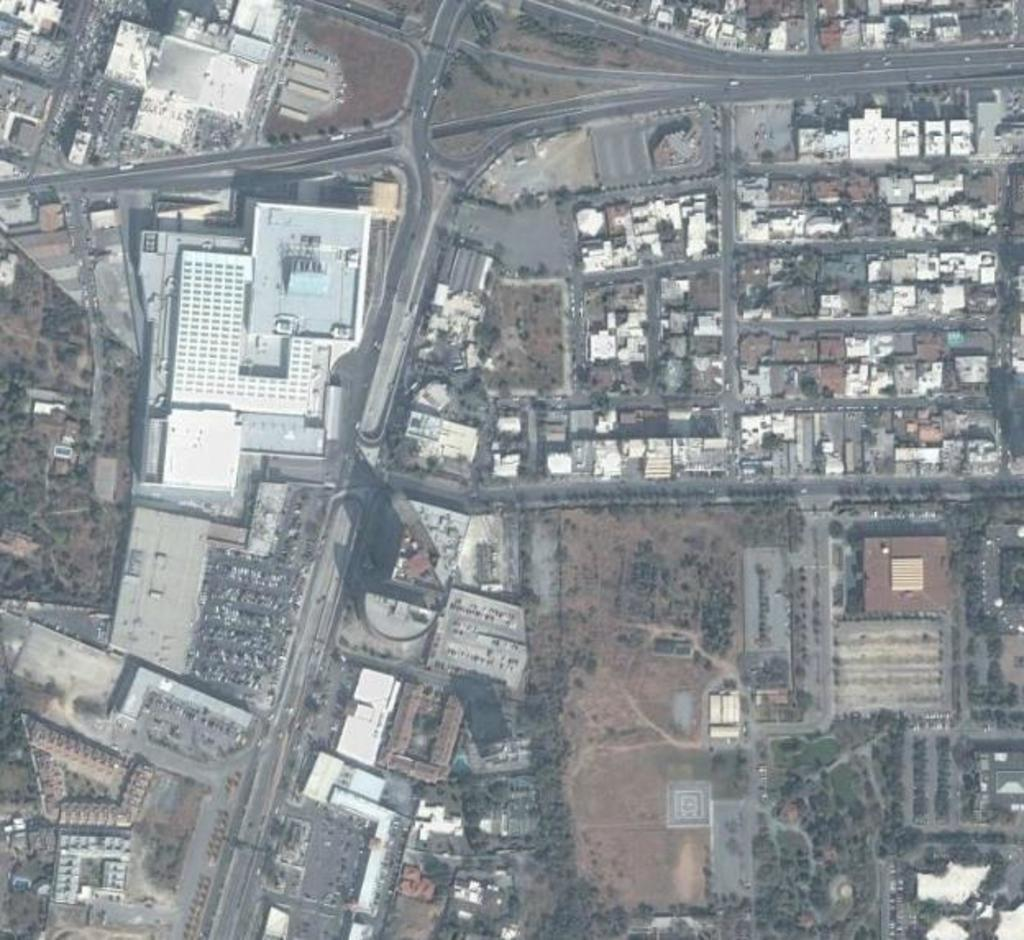What type of view is shown in the image? The image is an aerial view of a city. What structures can be seen in the city? There are buildings and houses in the image. What natural elements are present in the city? There are trees in the image. How are the buildings and houses connected in the city? There are roads in the image, and vehicles are present on the roads. Can you see any monkeys reading books in the trees in the image? There are no monkeys or books present in the image; it shows an aerial view of a city with trees, buildings, houses, and roads. 